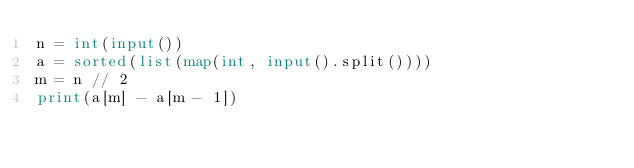Convert code to text. <code><loc_0><loc_0><loc_500><loc_500><_Python_>n = int(input())
a = sorted(list(map(int, input().split())))
m = n // 2
print(a[m] - a[m - 1])
</code> 